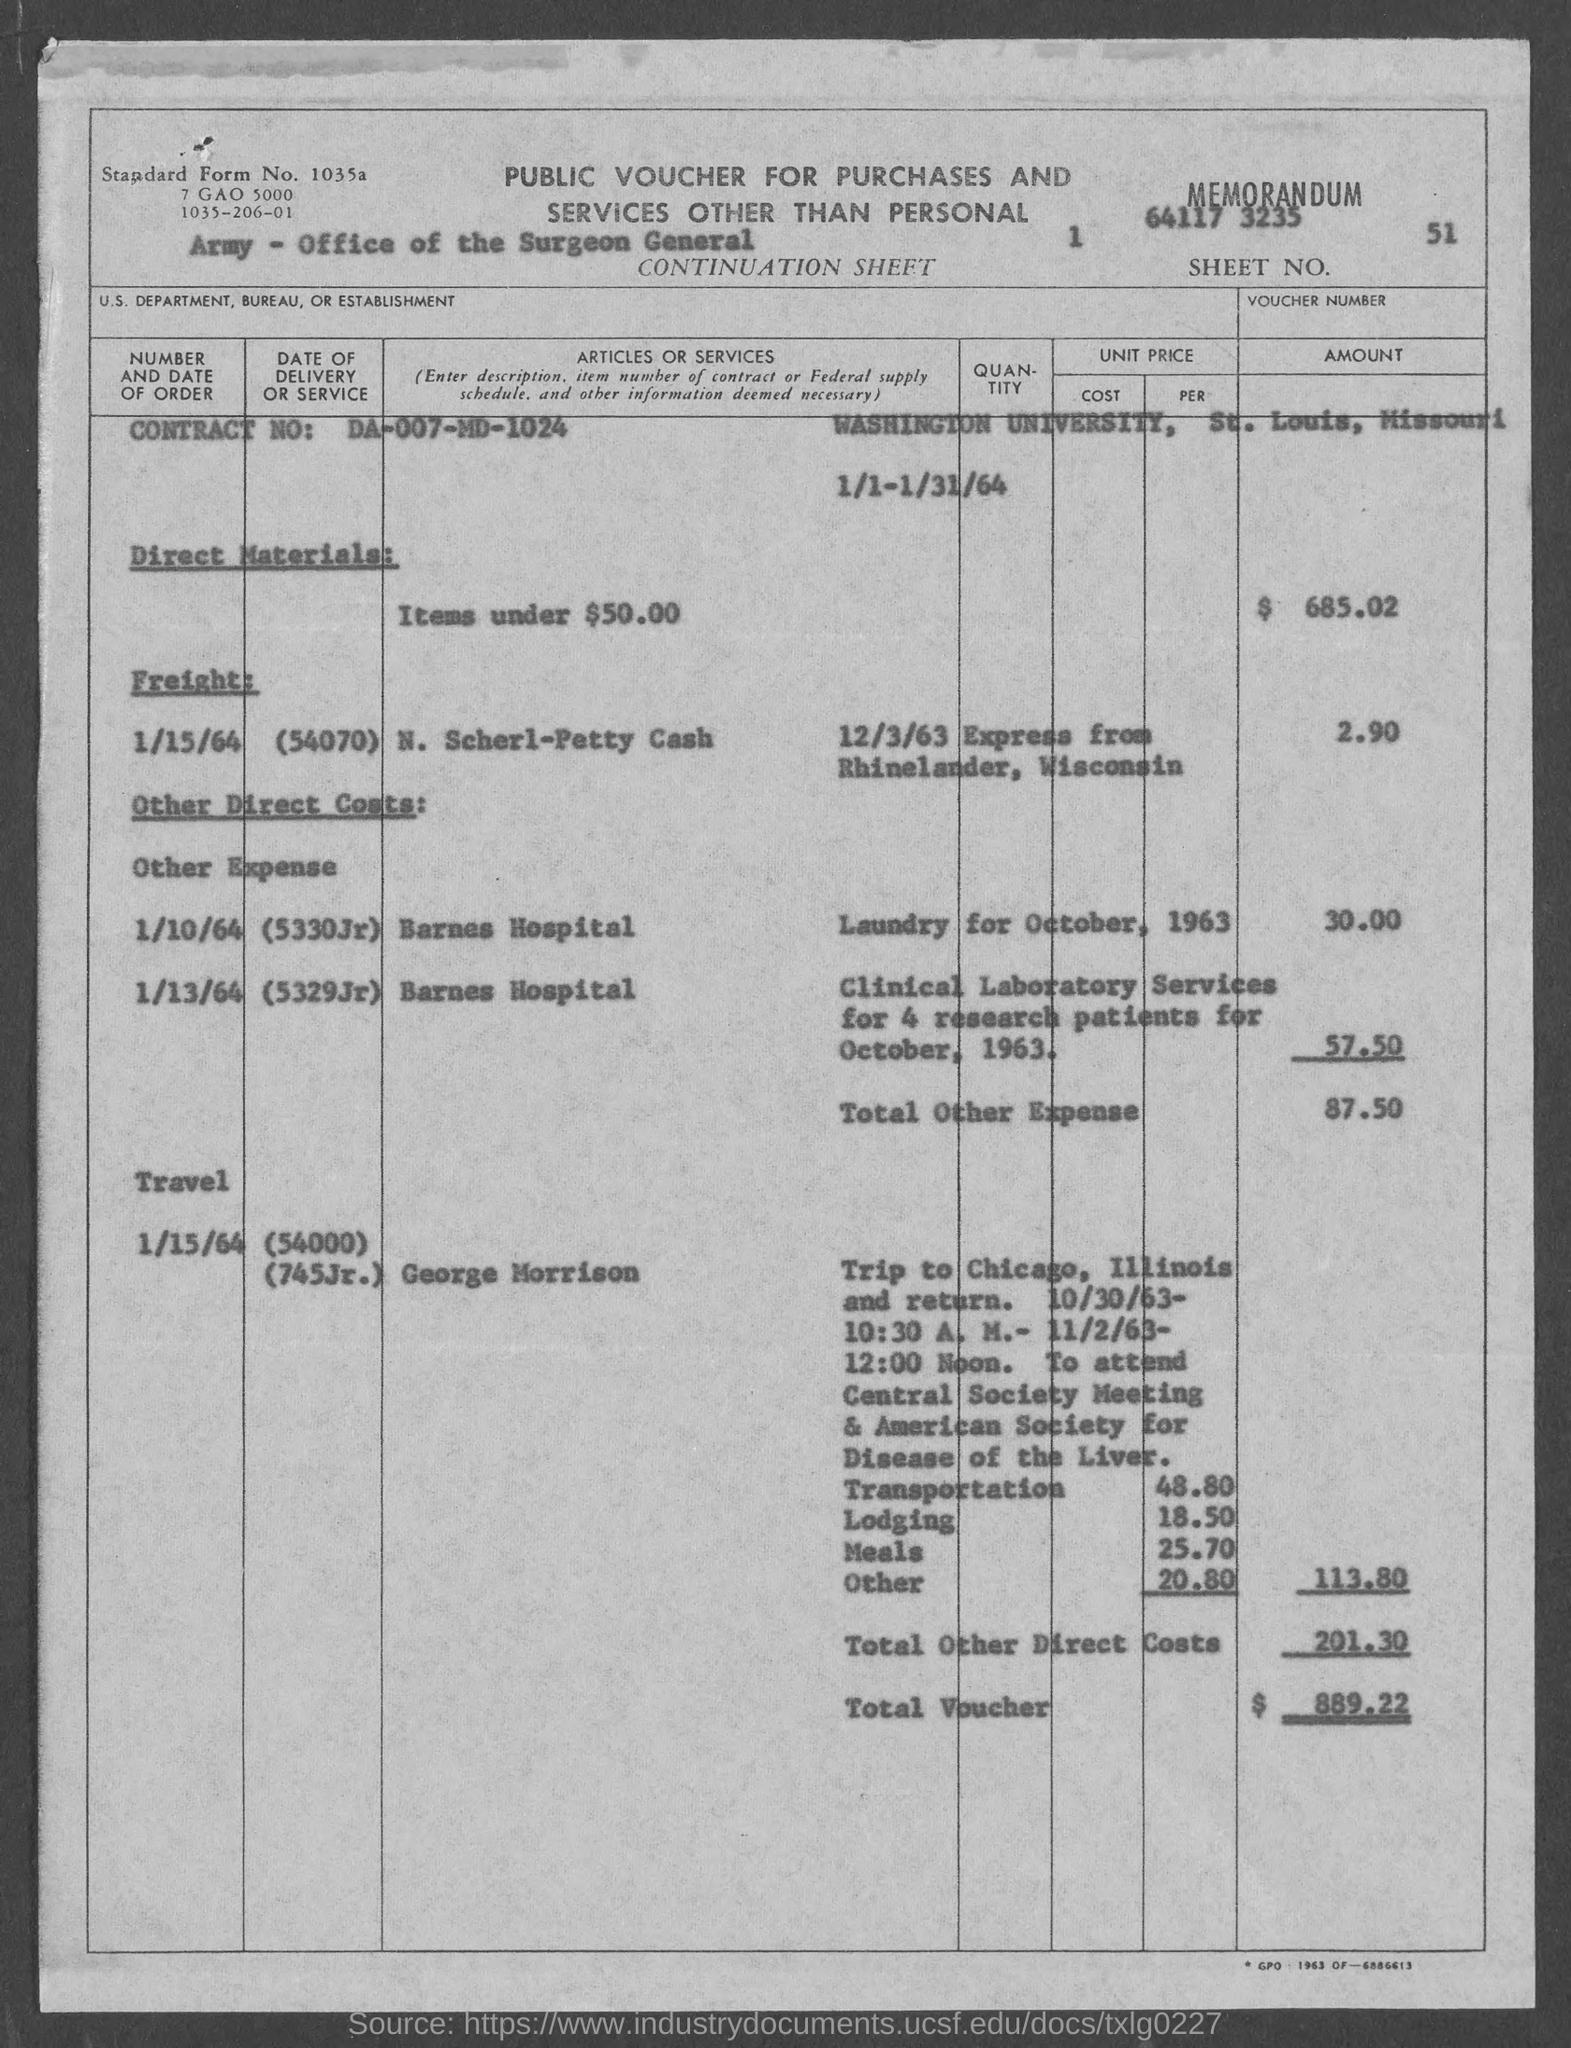What is the "contract no." mentioned?
Give a very brief answer. DA-007-MD-1024. How many "research patients" were offered "Clinical laboratory services" in "October, 1963"?
Keep it short and to the point. 4. What is the value given against "Lodging"?
Make the answer very short. 18.50. Where is the "Washington University" located?
Provide a short and direct response. St. Louis. What is the date mentioned under the subheading "Freight"?
Your answer should be compact. 1/15/64. 